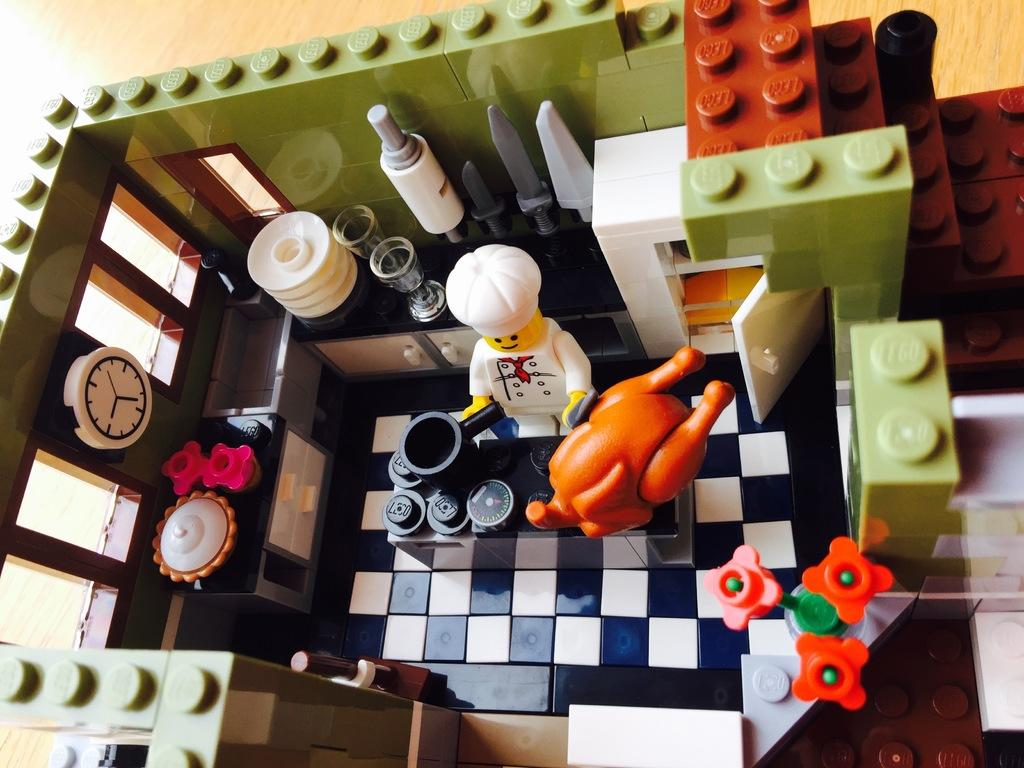What objects are on the floor in the image? There are toys present on the floor. Can you describe the types of toys visible in the image? Unfortunately, the specific types of toys cannot be determined from the provided facts. Are there any other objects or people visible in the image? The facts only mention the presence of toys on the floor, so no other objects or people can be confirmed. What type of form does the steam take in the image? There is no steam present in the image, as it only features toys on the floor. Who is the partner of the person in the image? There is no person present in the image, only toys on the floor. 